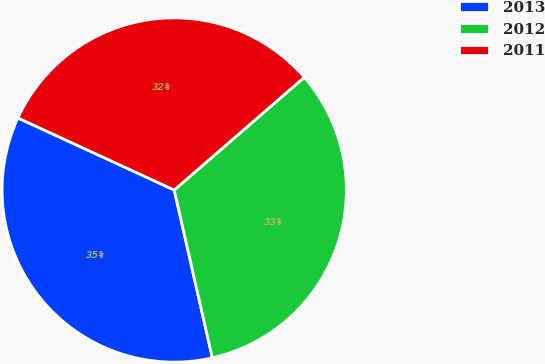<chart> <loc_0><loc_0><loc_500><loc_500><pie_chart><fcel>2013<fcel>2012<fcel>2011<nl><fcel>35.43%<fcel>32.81%<fcel>31.76%<nl></chart> 